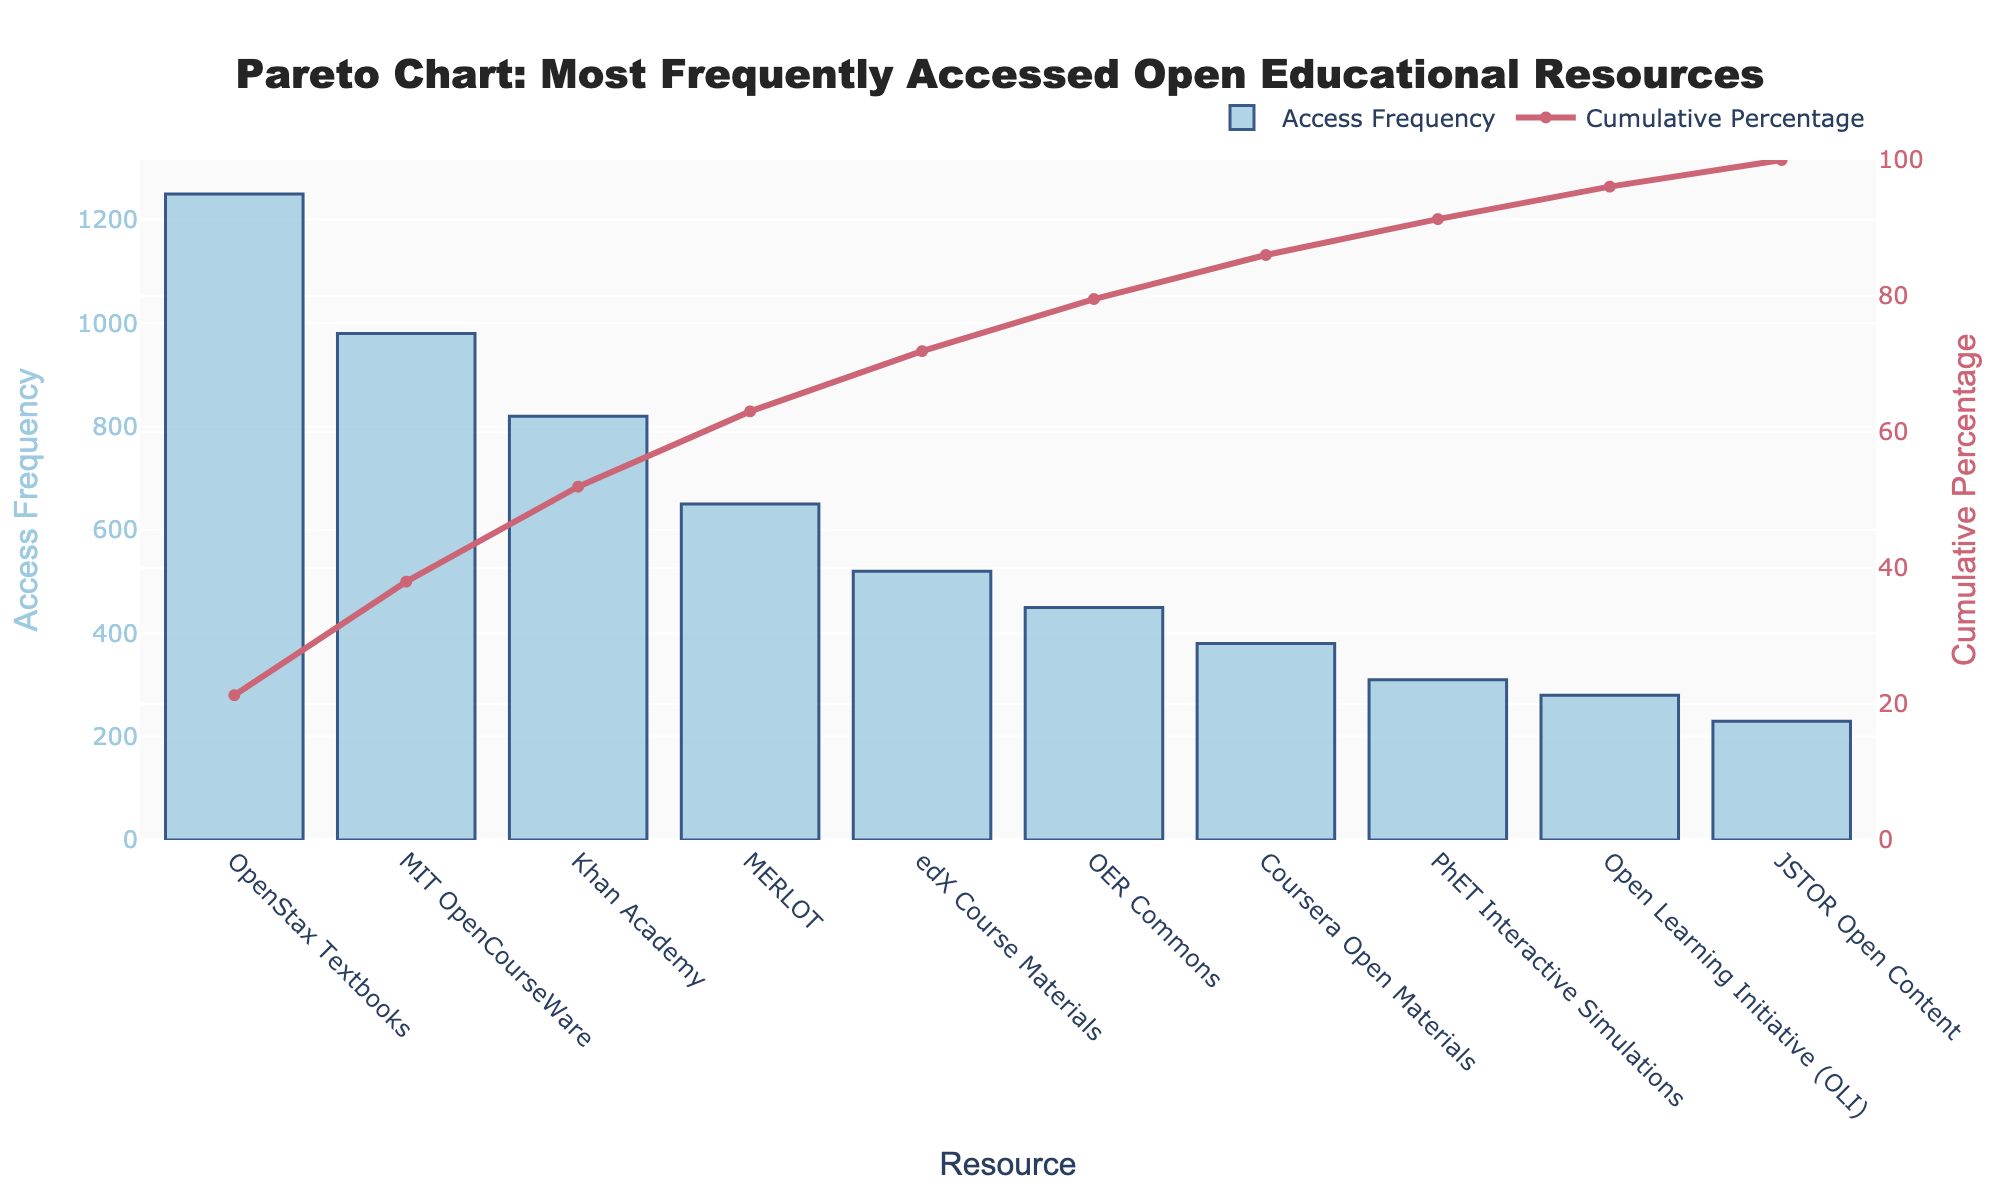What's the title of the figure? The title is usually located at the top of the figure. It describes the main theme or focus of the chart.
Answer: Pareto Chart: Most Frequently Accessed Open Educational Resources What is the access frequency of MIT OpenCourseWare? Look at the bars in the chart. Find the bar labeled "MIT OpenCourseWare" and read its value on the y-axis.
Answer: 980 What is the resource with the lowest access frequency? Check the bars in the chart. The bar with the smallest height represents the resource with the lowest access frequency.
Answer: JSTOR Open Content Which resource has the highest cumulative percentage that is less than 50%? Identify the cumulative percentage line and find the highest resource below the 50% mark. This requires inspecting the cumulative percentage values of each resource up to the one that crosses 50%.
Answer: Khan Academy Which resource shows a sharp increase in the cumulative percentage after it? Observe the line chart within the Pareto chart. Look for a resource after which there is a noticeable jump in the percentage.
Answer: MIT OpenCourseWare How many resources have an access frequency greater than 500? Count the number of bars whose height exceeds the 500 mark on the y-axis.
Answer: Four (OpenStax Textbooks, MIT OpenCourseWare, Khan Academy, MERLOT) What cumulative percentage does MERLOT contribute to? Locate the bar corresponding to "MERLOT" and find its cumulative percentage value on the secondary y-axis.
Answer: 63.57% Compare the access frequency of edX Course Materials and OER Commons. Which one is higher? Identify the two bars for "edX Course Materials" and "OER Commons," then compare their heights or y-axis values.
Answer: edX Course Materials 